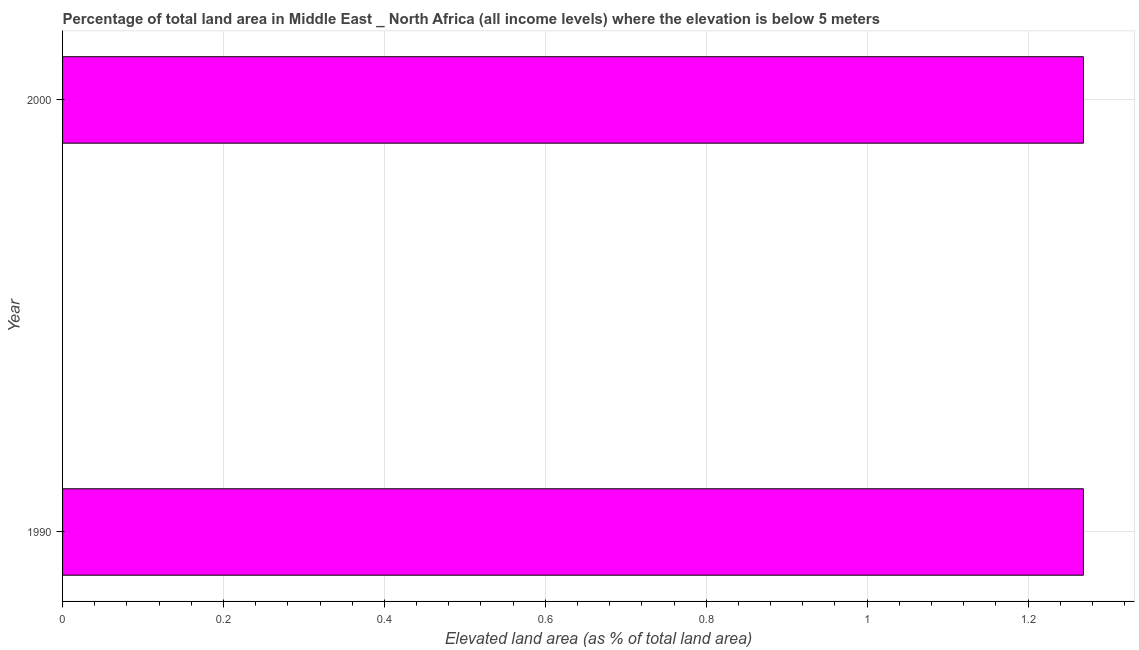What is the title of the graph?
Give a very brief answer. Percentage of total land area in Middle East _ North Africa (all income levels) where the elevation is below 5 meters. What is the label or title of the X-axis?
Provide a succinct answer. Elevated land area (as % of total land area). What is the total elevated land area in 1990?
Give a very brief answer. 1.27. Across all years, what is the maximum total elevated land area?
Your answer should be very brief. 1.27. Across all years, what is the minimum total elevated land area?
Your response must be concise. 1.27. In which year was the total elevated land area maximum?
Offer a terse response. 2000. What is the sum of the total elevated land area?
Ensure brevity in your answer.  2.54. What is the average total elevated land area per year?
Keep it short and to the point. 1.27. What is the median total elevated land area?
Keep it short and to the point. 1.27. In how many years, is the total elevated land area greater than 0.2 %?
Ensure brevity in your answer.  2. Do a majority of the years between 1990 and 2000 (inclusive) have total elevated land area greater than 0.76 %?
Offer a very short reply. Yes. What is the ratio of the total elevated land area in 1990 to that in 2000?
Provide a succinct answer. 1. In how many years, is the total elevated land area greater than the average total elevated land area taken over all years?
Give a very brief answer. 1. How many bars are there?
Your response must be concise. 2. Are all the bars in the graph horizontal?
Provide a succinct answer. Yes. Are the values on the major ticks of X-axis written in scientific E-notation?
Offer a very short reply. No. What is the Elevated land area (as % of total land area) of 1990?
Provide a short and direct response. 1.27. What is the Elevated land area (as % of total land area) of 2000?
Ensure brevity in your answer.  1.27. What is the difference between the Elevated land area (as % of total land area) in 1990 and 2000?
Offer a very short reply. -7e-5. What is the ratio of the Elevated land area (as % of total land area) in 1990 to that in 2000?
Your answer should be compact. 1. 